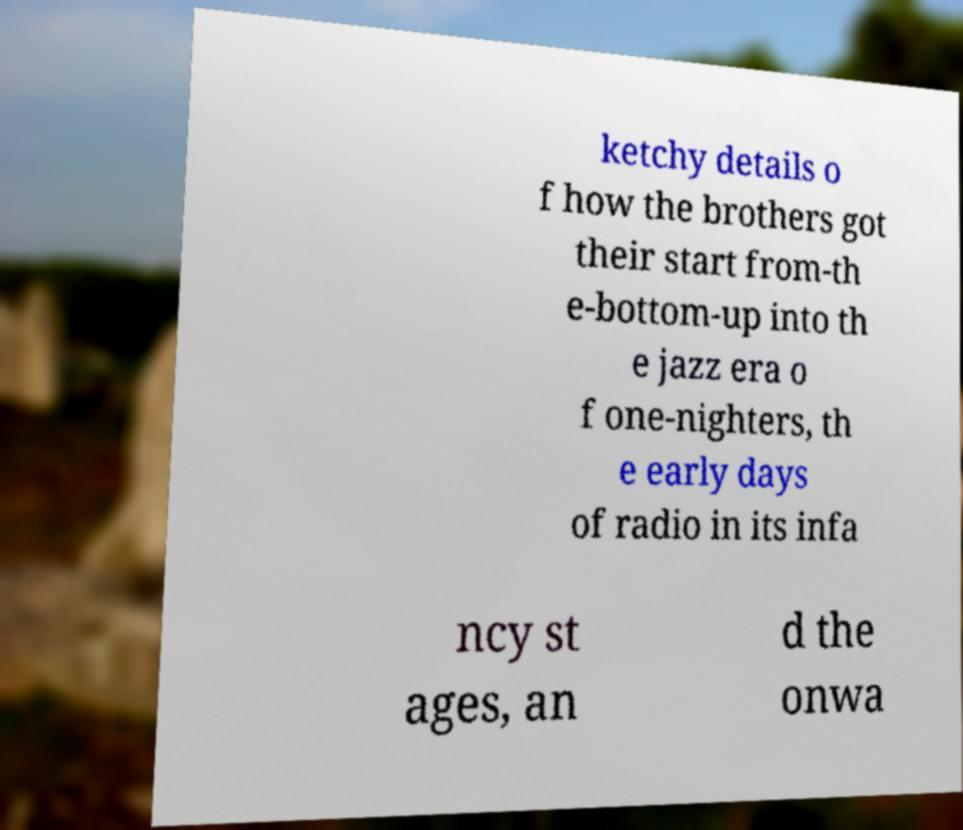What messages or text are displayed in this image? I need them in a readable, typed format. ketchy details o f how the brothers got their start from-th e-bottom-up into th e jazz era o f one-nighters, th e early days of radio in its infa ncy st ages, an d the onwa 